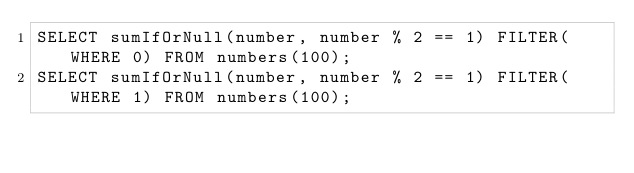Convert code to text. <code><loc_0><loc_0><loc_500><loc_500><_SQL_>SELECT sumIfOrNull(number, number % 2 == 1) FILTER(WHERE 0) FROM numbers(100);
SELECT sumIfOrNull(number, number % 2 == 1) FILTER(WHERE 1) FROM numbers(100);
</code> 